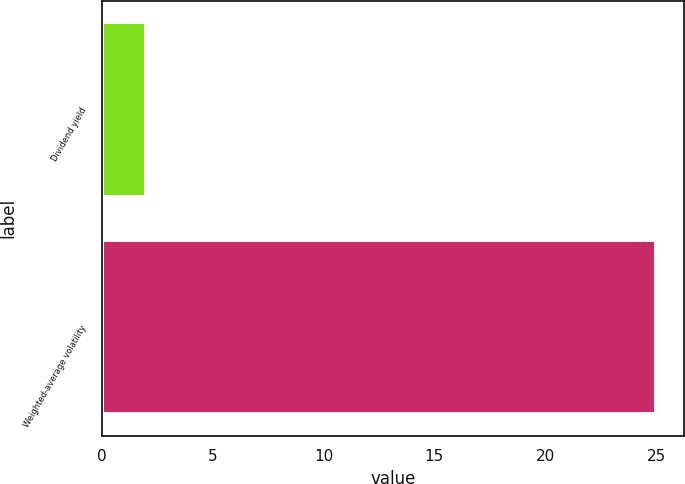Convert chart to OTSL. <chart><loc_0><loc_0><loc_500><loc_500><bar_chart><fcel>Dividend yield<fcel>Weighted-average volatility<nl><fcel>2<fcel>25<nl></chart> 